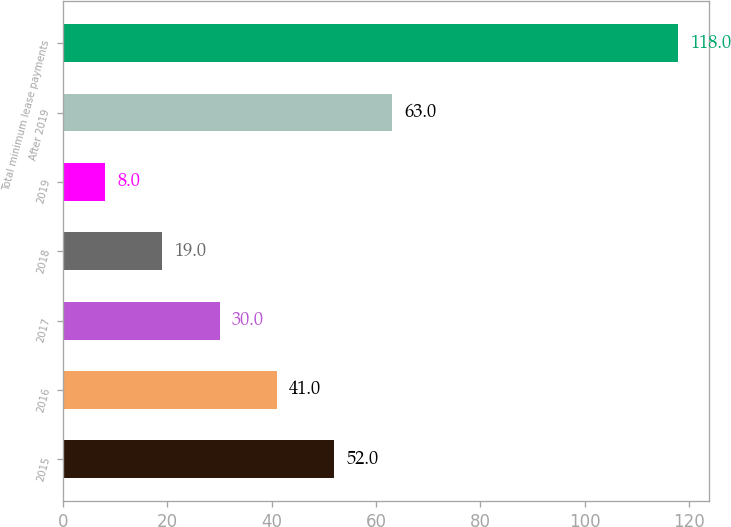Convert chart. <chart><loc_0><loc_0><loc_500><loc_500><bar_chart><fcel>2015<fcel>2016<fcel>2017<fcel>2018<fcel>2019<fcel>After 2019<fcel>Total minimum lease payments<nl><fcel>52<fcel>41<fcel>30<fcel>19<fcel>8<fcel>63<fcel>118<nl></chart> 